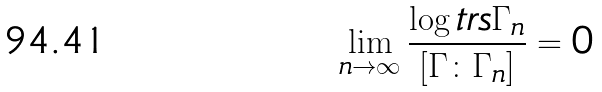Convert formula to latex. <formula><loc_0><loc_0><loc_500><loc_500>\lim _ { n \rightarrow \infty } \frac { \log t r s \Gamma _ { n } } { [ \Gamma \colon \Gamma _ { n } ] } = 0</formula> 